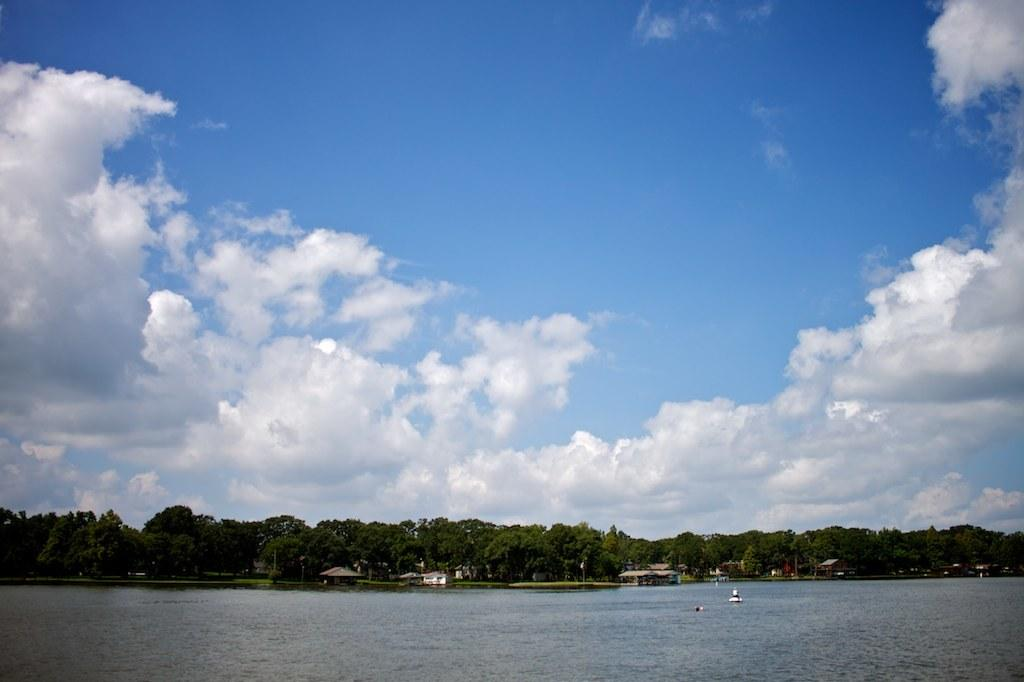What type of natural feature is present in the image? There is a river in the image. What structures are located near the river? There are houses in front of the river. What type of vegetation is behind the houses? There are trees behind the houses. What can be seen in the background of the image? The sky is visible in the background of the image. What brand of toothpaste is being used by the father in the image? There is no father or toothpaste present in the image. What is the desire of the person in the image? There is no person or desire mentioned in the image; it only features a river, houses, trees, and the sky. 